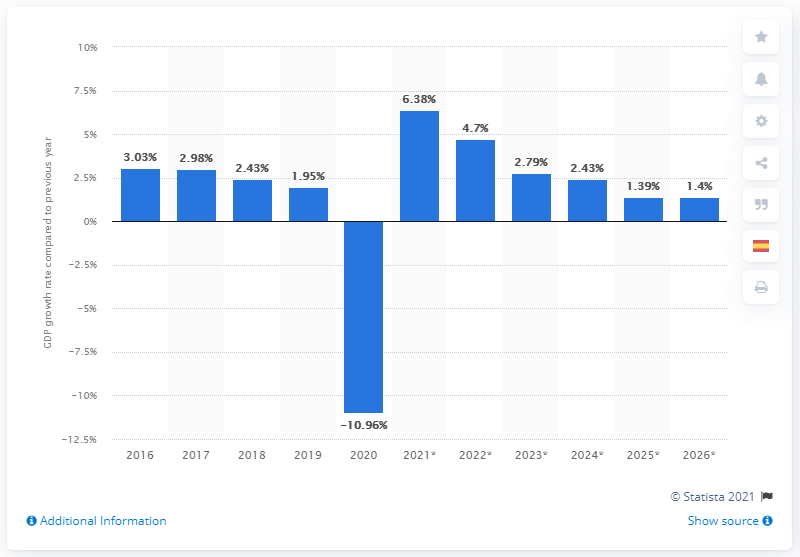Outline some significant characteristics in this image. In 2019, Spain's real GDP growth was 1.95%. 